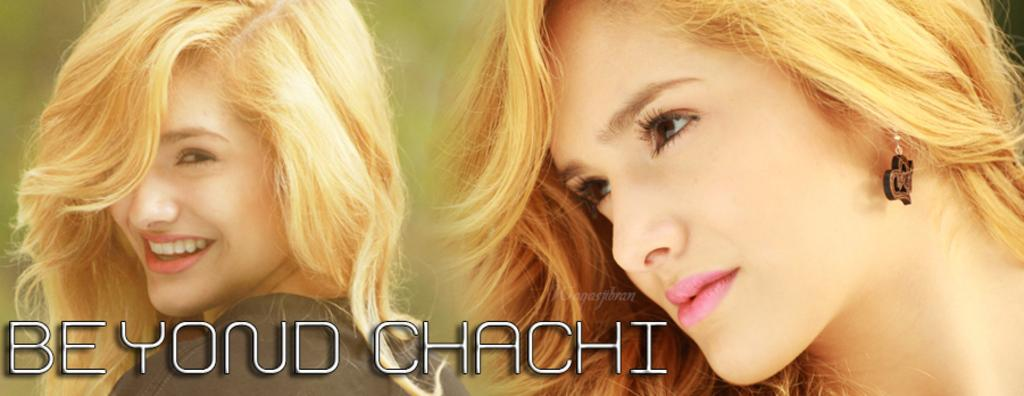What is the main subject in the image? There is an object that appears to be a poster in the image. What can be seen on the poster? The poster contains pictures of two people. Is there any text present in the image? Yes, there is text at the bottom of the image. What type of arithmetic problem can be solved using the copper coins depicted on the poster? There are no copper coins depicted on the poster, and therefore no arithmetic problem can be solved using them. 